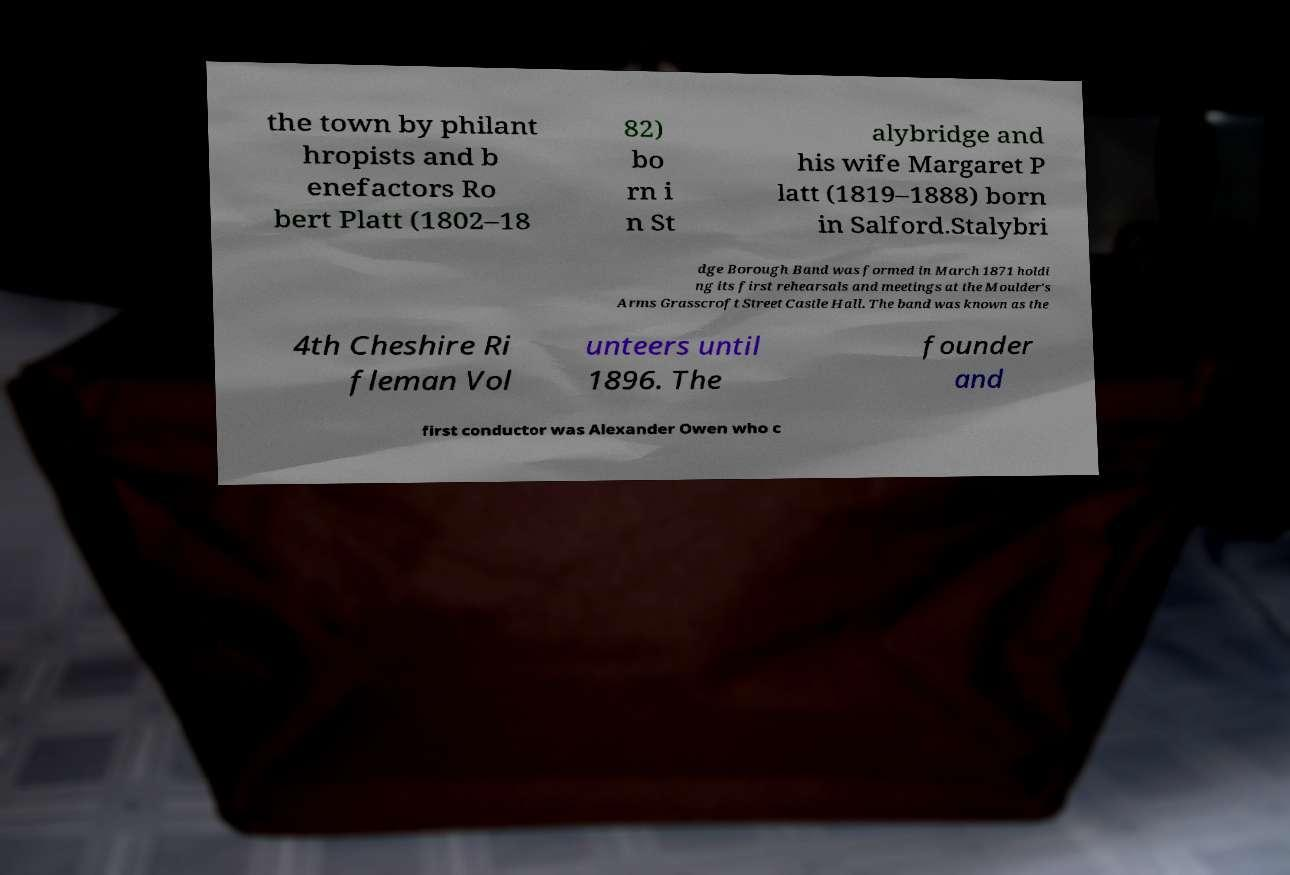Can you read and provide the text displayed in the image?This photo seems to have some interesting text. Can you extract and type it out for me? the town by philant hropists and b enefactors Ro bert Platt (1802–18 82) bo rn i n St alybridge and his wife Margaret P latt (1819–1888) born in Salford.Stalybri dge Borough Band was formed in March 1871 holdi ng its first rehearsals and meetings at the Moulder's Arms Grasscroft Street Castle Hall. The band was known as the 4th Cheshire Ri fleman Vol unteers until 1896. The founder and first conductor was Alexander Owen who c 